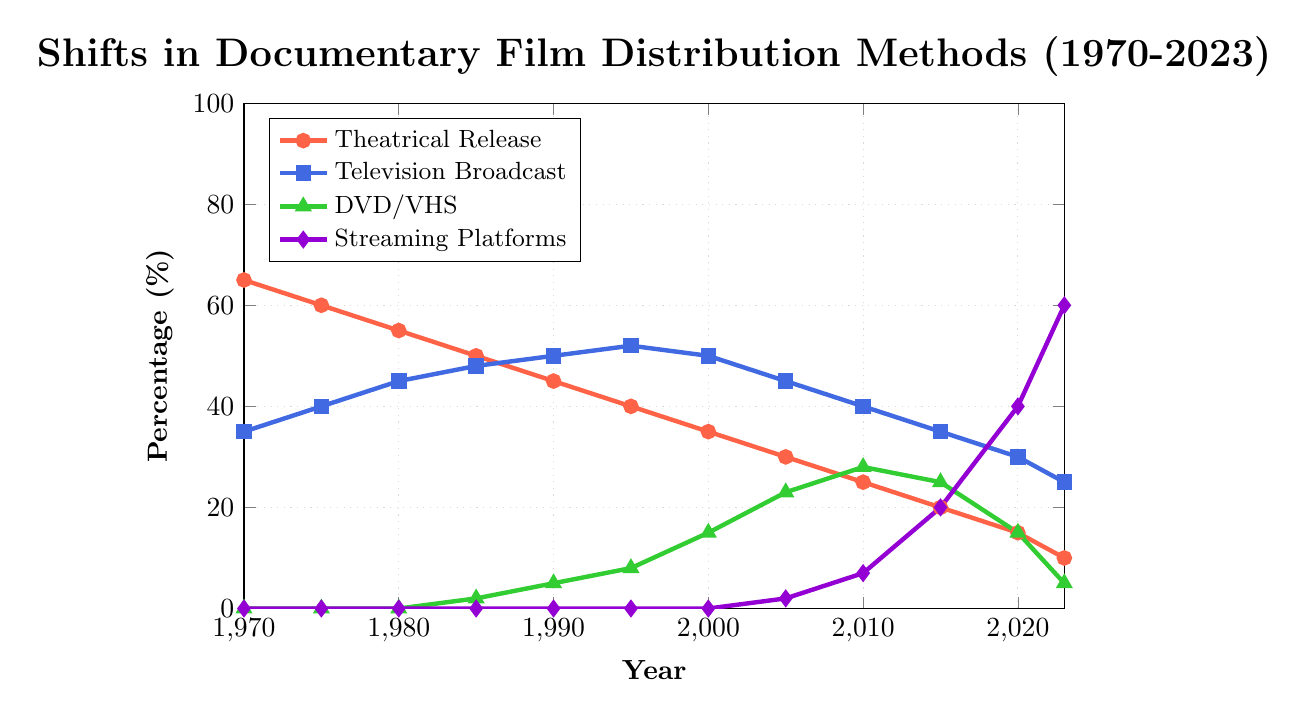Which distribution method had the highest percentage in 1970? In 1970, the theatrical release had the highest percentage, indicated by the highest point on its line, which is at 65%.
Answer: Theatrical Release Comparing 1985 and 2023, which distribution method saw the most significant increase in percentage? To find the most significant increase, compare the percentages for each method in 1985 and 2023. Streaming platforms increased from 0% in 1985 to 60% in 2023, which is the largest increase.
Answer: Streaming Platforms What was the percentage difference between Theatrical Release and Streaming Platforms in 2020? In 2020, Theatrical Release was at 15% and Streaming Platforms were at 40%. The difference is 40% - 15% = 25%.
Answer: 25% Which year saw an equal percentage distribution in Television Broadcast and Streaming Platforms? Look for a year where both Television Broadcast and Streaming Platforms intersect. In 2005, both were close, but the exact year was 2020 where Television Broadcast had 30% and Streaming Platforms had 40%, both lines don't cross.
Answer: 2020 What is the combined percentage of DVD/VHS and Streaming Platforms in 2010? In 2010, DVD/VHS was at 28% and Streaming Platforms were at 7%. The combined percentage is 28% + 7% = 35%.
Answer: 35% How many years did Theatrical Release maintain a higher percentage than Television Broadcast? Theatrical Release maintained higher percentages from 1970 to 1980. Count the individual years: 1970, 1975, and 1980, totaling 3 years.
Answer: 3 years By how much did the percentage of Streaming Platforms increase from 2005 to 2023? In 2005, Streaming Platforms were at 2%, and in 2023, they reached 60%. The increase is 60% - 2% = 58%.
Answer: 58% In which year did DVD/VHS reach its peak percentage, and what was the value? The peak value for DVD/VHS occurs at its highest point on the plot. This is in 2010, where it reached 28%.
Answer: 2010, 28% What was the trend for Television Broadcast from 2000 to 2023? Television Broadcast started at 50% in 2000 and steadily declined to 25% in 2023. This indicates a downward trend.
Answer: Downward Trend 